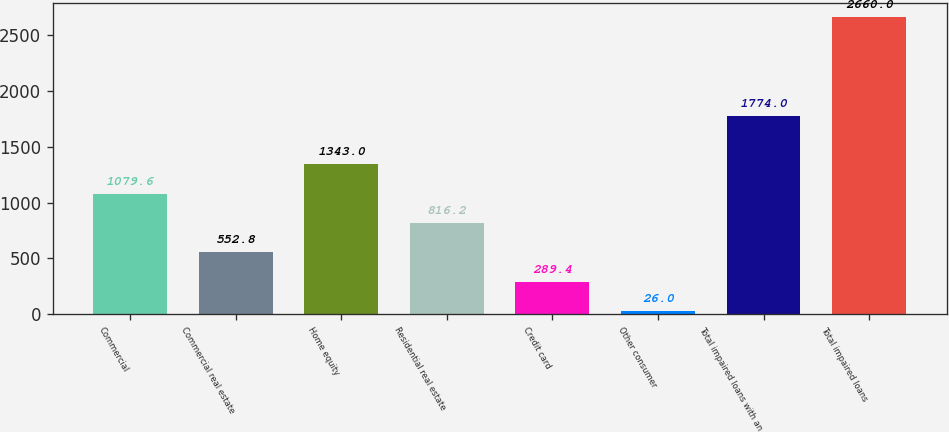<chart> <loc_0><loc_0><loc_500><loc_500><bar_chart><fcel>Commercial<fcel>Commercial real estate<fcel>Home equity<fcel>Residential real estate<fcel>Credit card<fcel>Other consumer<fcel>Total impaired loans with an<fcel>Total impaired loans<nl><fcel>1079.6<fcel>552.8<fcel>1343<fcel>816.2<fcel>289.4<fcel>26<fcel>1774<fcel>2660<nl></chart> 